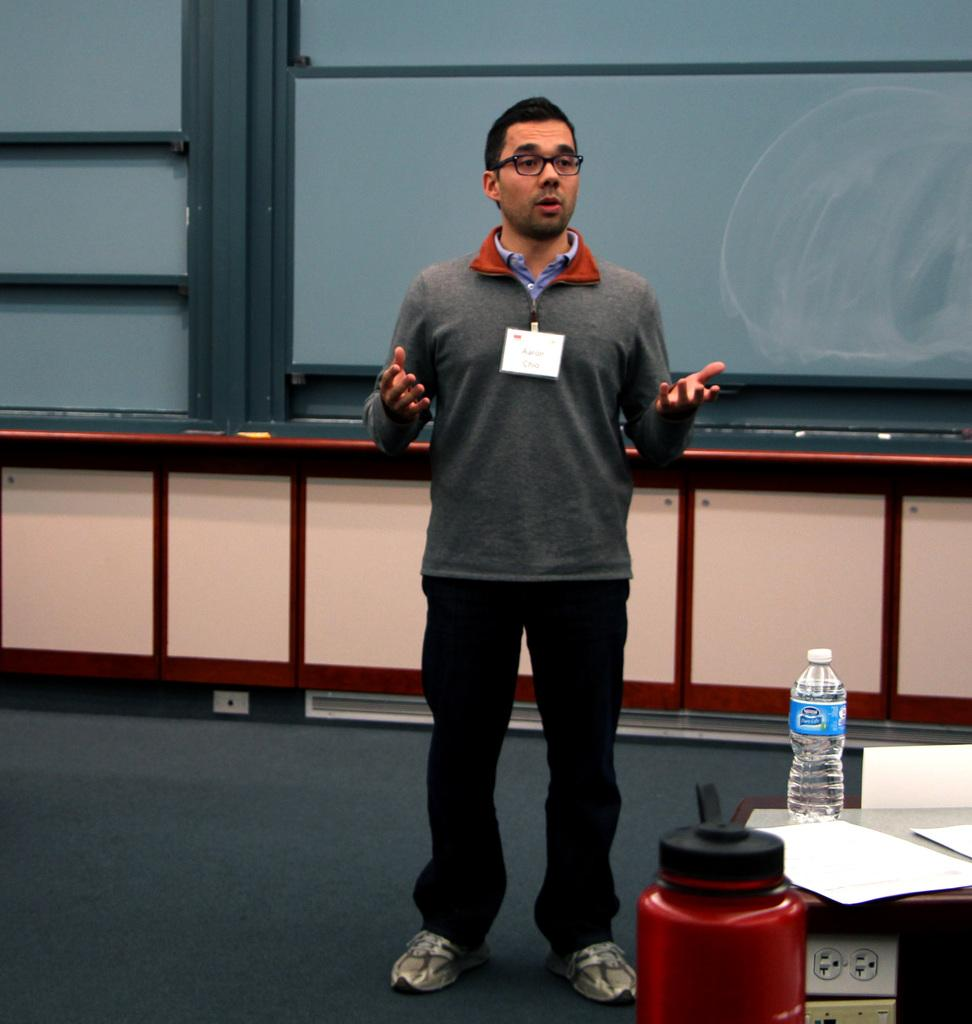What is the man in the image doing? The man is standing and speaking in the image. What objects are on the table in the image? There is a water bottle and papers on the table in the image. What type of leather material is covering the test in the image? There is no test or leather material present in the image. 